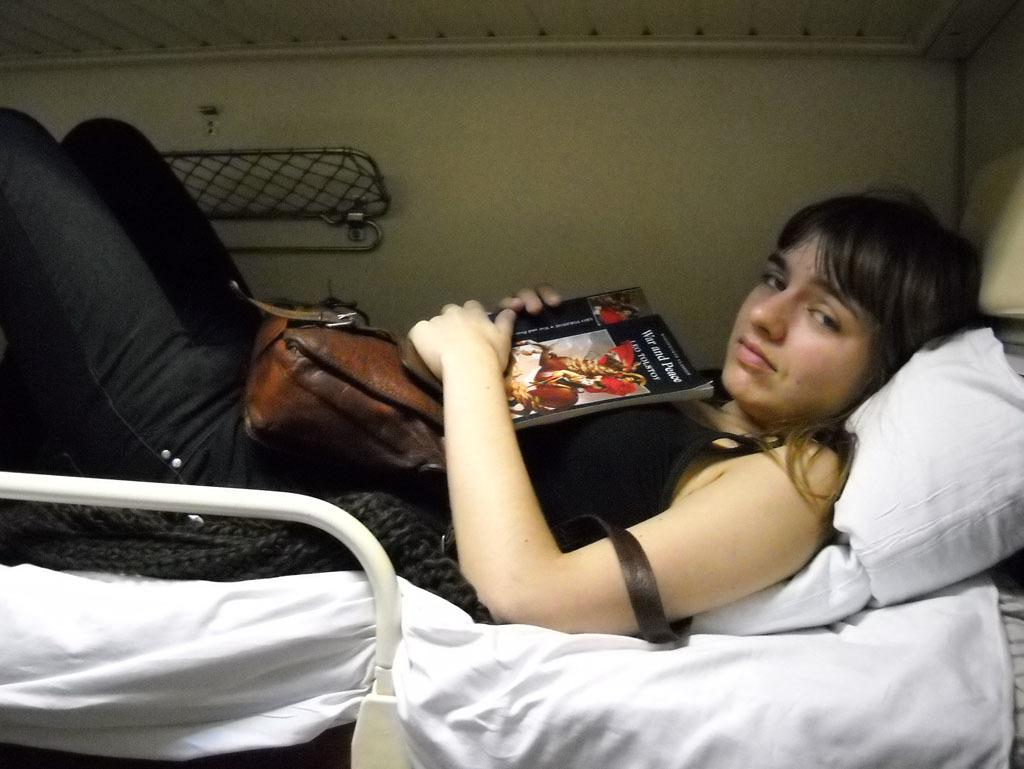What is the person in the image doing? There is a person lying on the bed in the image. What object can be seen near the person? There is a bag in the image. What else is present in the image besides the person and the bag? There is a book and a pillow in the image. What type of bite can be seen on the person's arm in the image? There is no bite visible on the person's arm in the image. How many books are present in the image? There is only one book present in the image. 